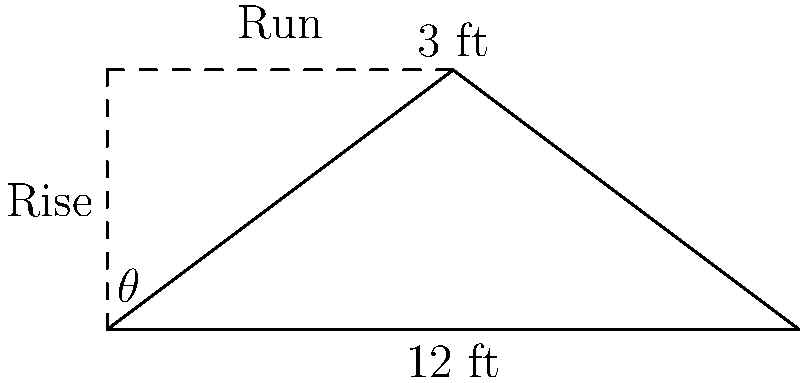You're helping a friend build a new Louisiana-style home with a pitched roof. The roof has a run of 12 feet and a rise of 3 feet. What is the angle $\theta$ of the roof pitch? To find the angle of the roof pitch, we can use basic trigonometry. Here's how to solve it step-by-step:

1. In a right triangle formed by the roof, we know:
   - The rise (vertical height) = 3 feet
   - The run (horizontal distance) = 12 feet

2. The tangent of an angle in a right triangle is the ratio of the opposite side to the adjacent side.
   In this case: $\tan(\theta) = \frac{\text{rise}}{\text{run}} = \frac{3}{12}$

3. Simplify the fraction: $\tan(\theta) = \frac{1}{4}$

4. To find the angle $\theta$, we need to use the inverse tangent (arctan or $\tan^{-1}$):
   $\theta = \tan^{-1}(\frac{1}{4})$

5. Using a calculator or trigonometric tables:
   $\theta \approx 14.04°$

6. Round to the nearest degree:
   $\theta \approx 14°$

So, the angle of the roof pitch is approximately 14 degrees.
Answer: $14°$ 